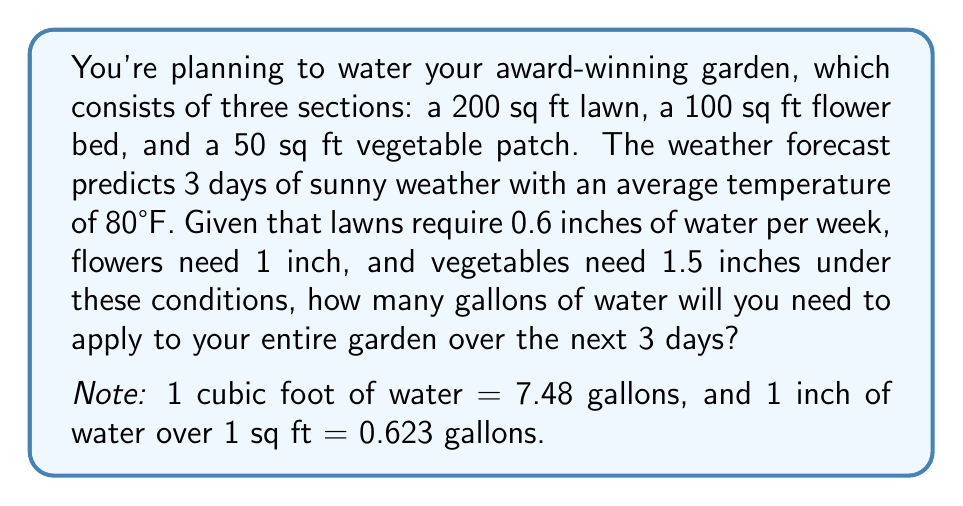What is the answer to this math problem? Let's break this down step-by-step:

1) First, calculate the weekly water requirements for each section:

   Lawn: 200 sq ft * 0.6 inches = 120 sq ft-inches
   Flowers: 100 sq ft * 1 inch = 100 sq ft-inches
   Vegetables: 50 sq ft * 1.5 inches = 75 sq ft-inches

2) Convert weekly requirements to 3-day requirements:

   Lawn: 120 * (3/7) = 51.43 sq ft-inches
   Flowers: 100 * (3/7) = 42.86 sq ft-inches
   Vegetables: 75 * (3/7) = 32.14 sq ft-inches

3) Convert sq ft-inches to gallons:

   Lawn: 51.43 * 0.623 = 32.04 gallons
   Flowers: 42.86 * 0.623 = 26.70 gallons
   Vegetables: 32.14 * 0.623 = 20.02 gallons

4) Sum up the total water needed:

   Total = 32.04 + 26.70 + 20.02 = 78.76 gallons

5) Round to the nearest whole number:

   79 gallons
Answer: 79 gallons 